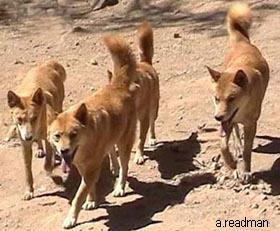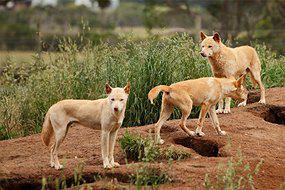The first image is the image on the left, the second image is the image on the right. Given the left and right images, does the statement "There are no more than two dingo's in the right image." hold true? Answer yes or no. No. 